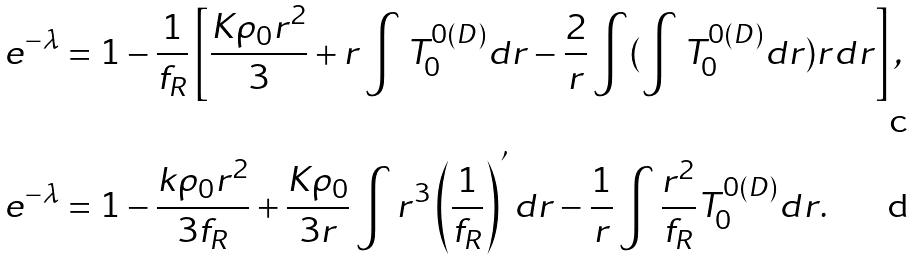<formula> <loc_0><loc_0><loc_500><loc_500>e ^ { - \lambda } & = 1 - \frac { 1 } { f _ { R } } \left [ \frac { K \rho _ { 0 } r ^ { 2 } } { 3 } + r \int T ^ { 0 ( D ) } _ { 0 } d r - \frac { 2 } { r } \int ( \int T ^ { 0 ( D ) } _ { 0 } d r ) r d r \right ] , \\ e ^ { - \lambda } & = 1 - \frac { k \rho _ { 0 } r ^ { 2 } } { 3 f _ { R } } + \frac { K \rho _ { 0 } } { 3 r } \int r ^ { 3 } \left ( \frac { 1 } { f _ { R } } \right ) ^ { ^ { \prime } } d r - \frac { 1 } { r } \int \frac { r ^ { 2 } } { f _ { R } } T ^ { 0 ( D ) } _ { 0 } d r .</formula> 